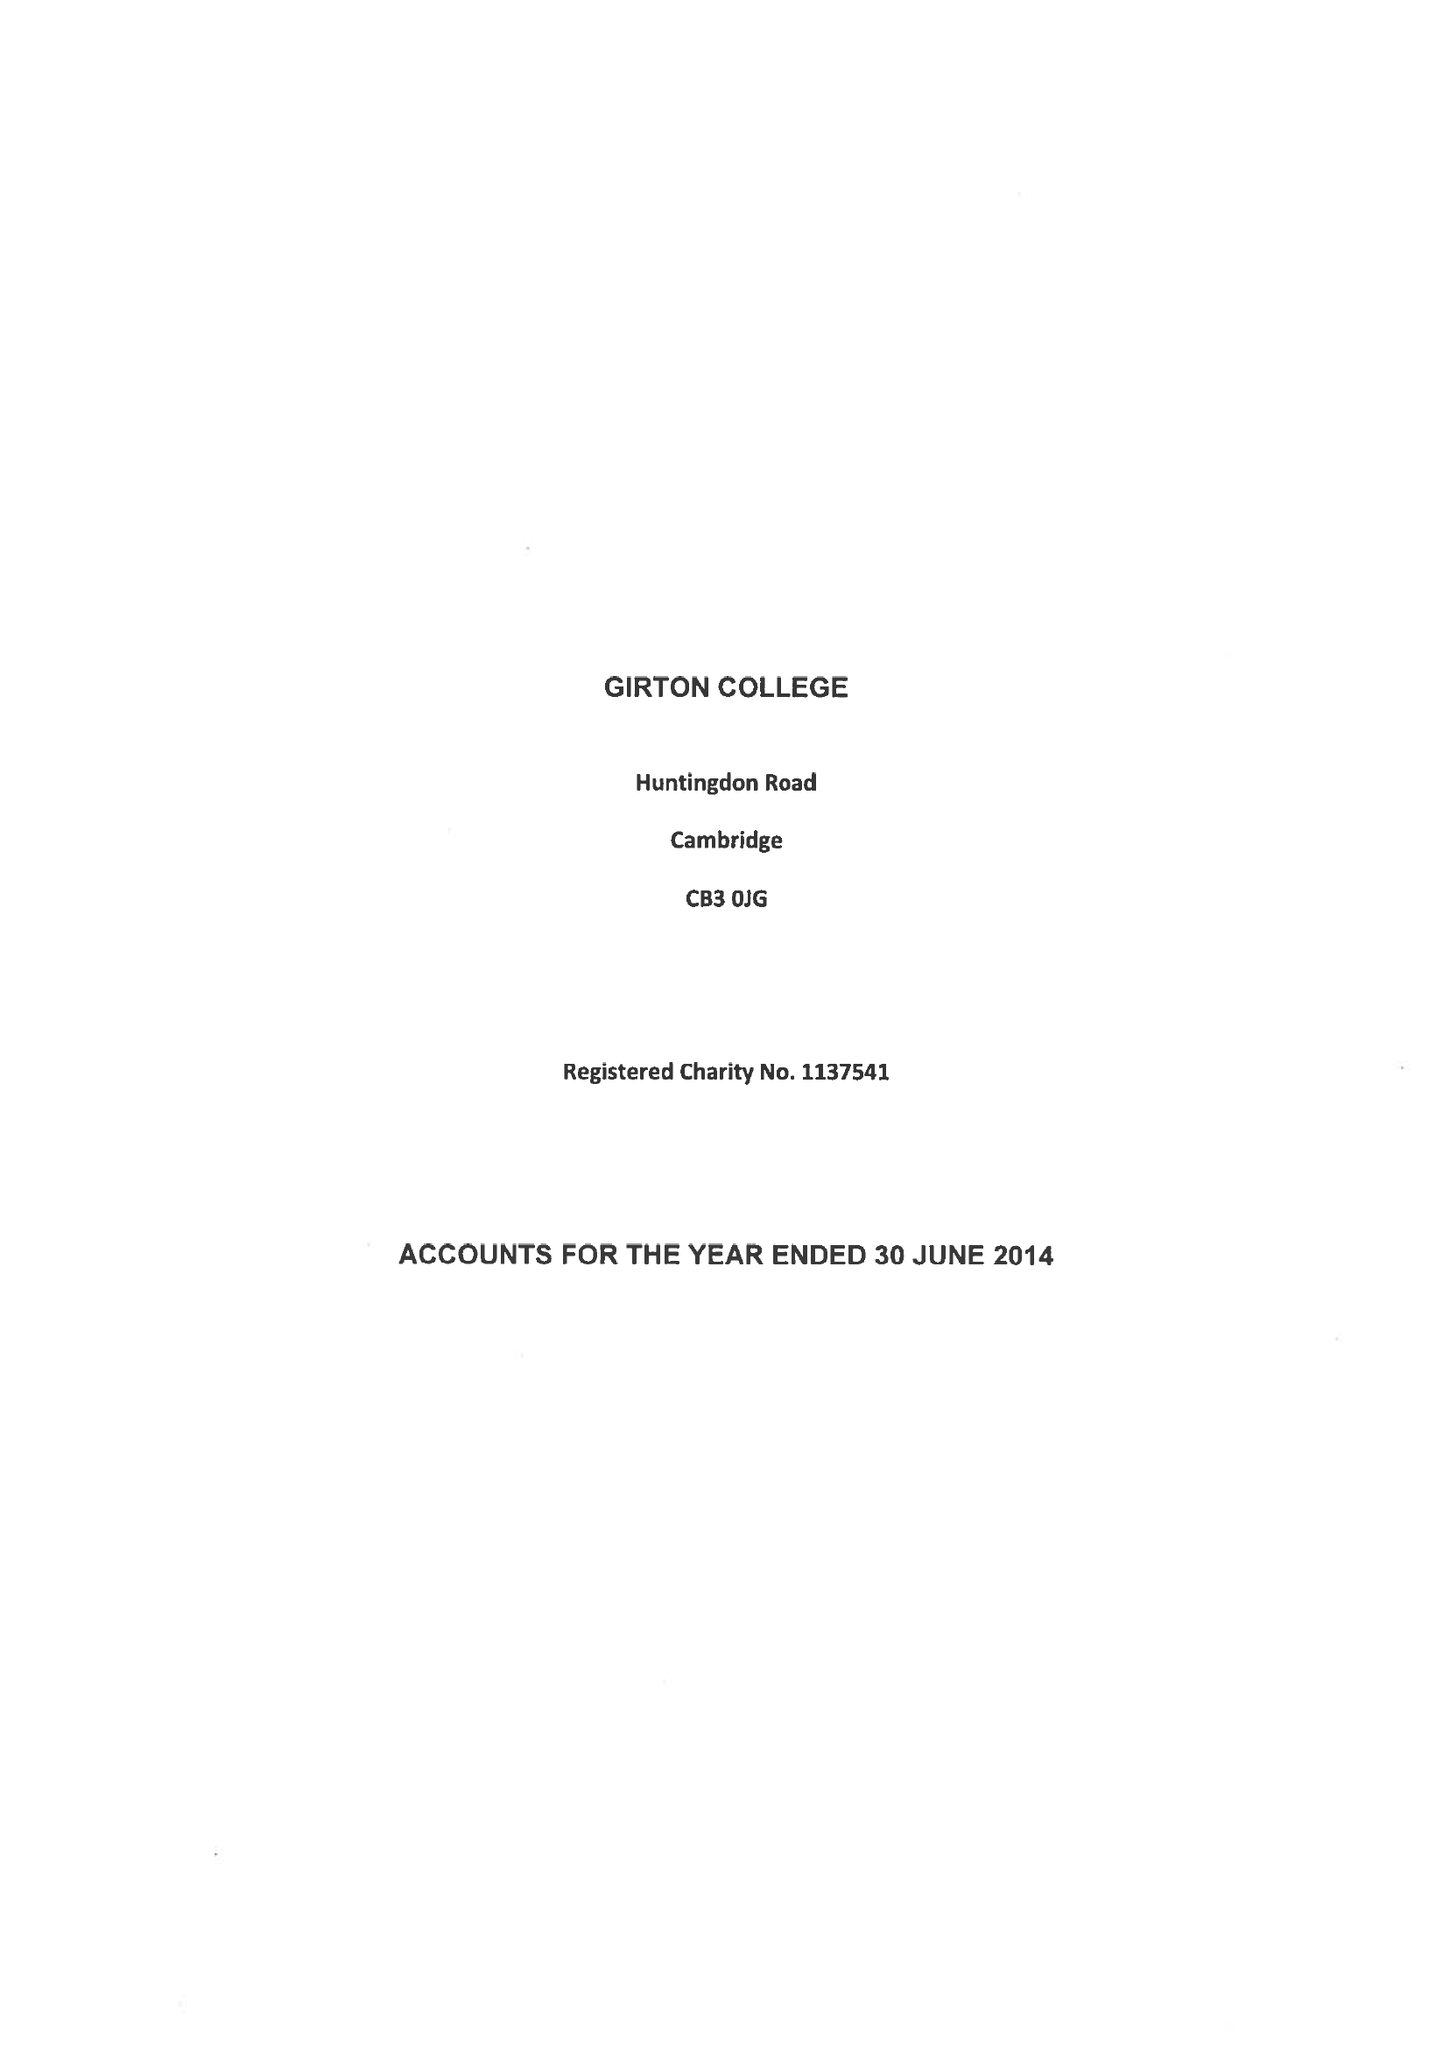What is the value for the income_annually_in_british_pounds?
Answer the question using a single word or phrase. 12753000.00 